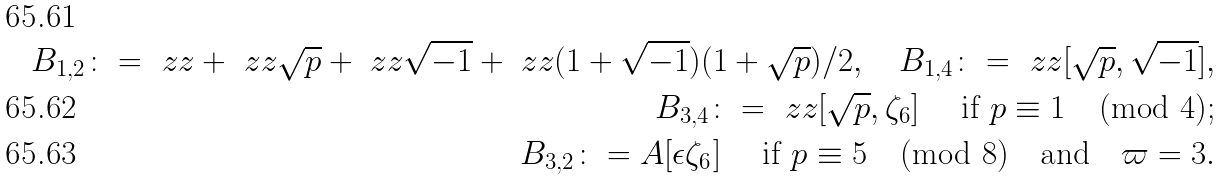Convert formula to latex. <formula><loc_0><loc_0><loc_500><loc_500>B _ { 1 , 2 } \colon = \ z z + \ z z \sqrt { p } + \ z z \sqrt { - 1 } + \ z z ( 1 + \sqrt { - 1 } ) ( 1 + \sqrt { p } ) / 2 , \quad B _ { 1 , 4 } \colon = \ z z [ \sqrt { p } , \sqrt { - 1 } ] , \\ B _ { 3 , 4 } \colon = \ z z [ \sqrt { p } , \zeta _ { 6 } ] \quad \text { if } p \equiv 1 \pmod { 4 } ; \\ B _ { 3 , 2 } \colon = A [ \epsilon \zeta _ { 6 } ] \quad \text { if } p \equiv 5 \pmod { 8 } \quad \text {and} \quad \varpi = 3 .</formula> 